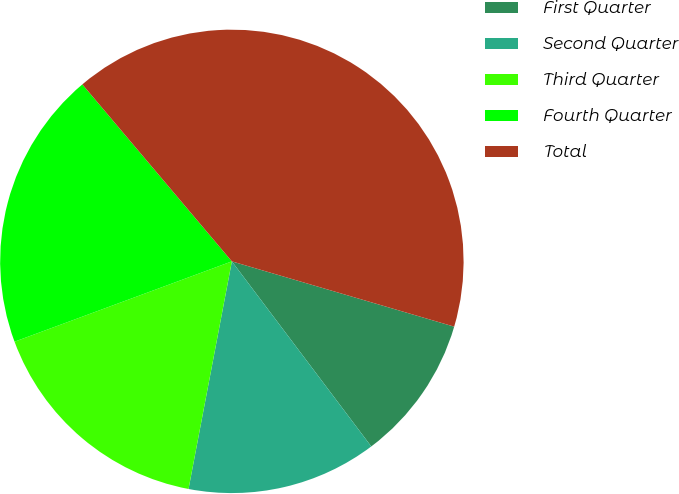Convert chart. <chart><loc_0><loc_0><loc_500><loc_500><pie_chart><fcel>First Quarter<fcel>Second Quarter<fcel>Third Quarter<fcel>Fourth Quarter<fcel>Total<nl><fcel>10.18%<fcel>13.27%<fcel>16.37%<fcel>19.47%<fcel>40.71%<nl></chart> 